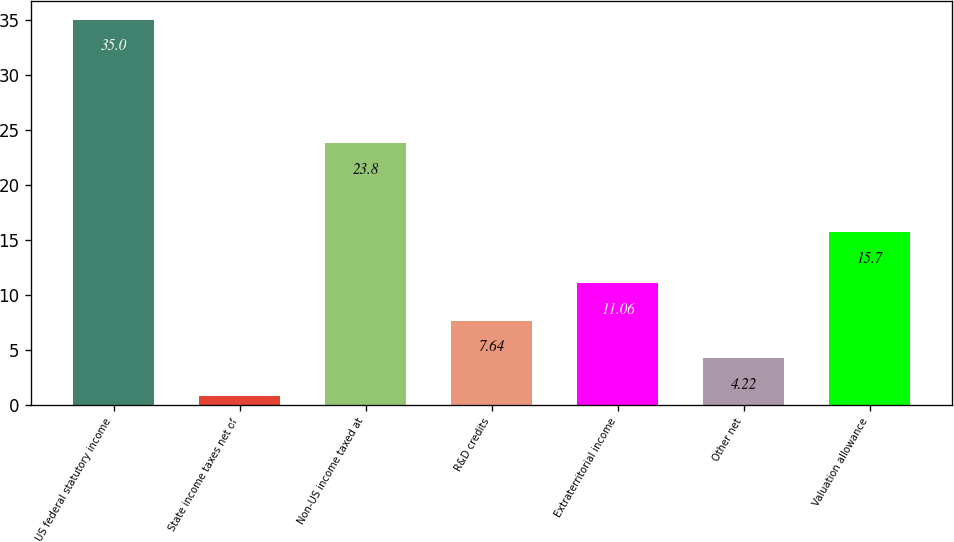<chart> <loc_0><loc_0><loc_500><loc_500><bar_chart><fcel>US federal statutory income<fcel>State income taxes net of<fcel>Non-US income taxed at<fcel>R&D credits<fcel>Extraterritorial income<fcel>Other net<fcel>Valuation allowance<nl><fcel>35<fcel>0.8<fcel>23.8<fcel>7.64<fcel>11.06<fcel>4.22<fcel>15.7<nl></chart> 